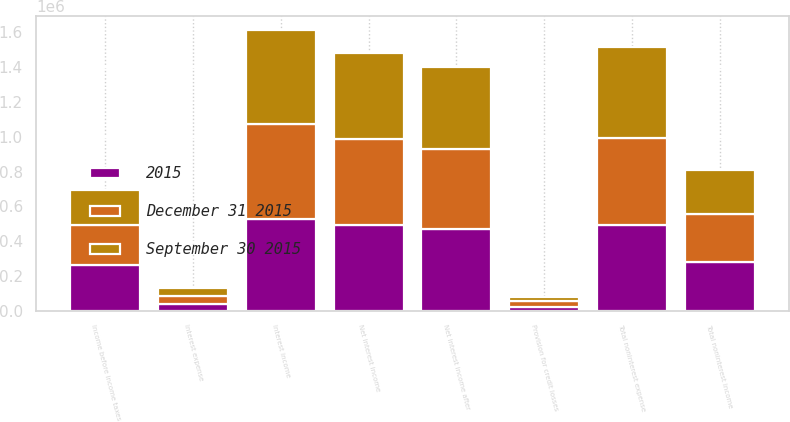Convert chart to OTSL. <chart><loc_0><loc_0><loc_500><loc_500><stacked_bar_chart><ecel><fcel>Interest income<fcel>Interest expense<fcel>Net interest income<fcel>Provision for credit losses<fcel>Net interest income after<fcel>Total noninterest income<fcel>Total noninterest expense<fcel>Income before income taxes<nl><fcel>December 31 2015<fcel>544153<fcel>47242<fcel>496911<fcel>36468<fcel>460443<fcel>272215<fcel>498766<fcel>233892<nl><fcel>September 30 2015<fcel>538477<fcel>43022<fcel>495455<fcel>22476<fcel>472979<fcel>253119<fcel>526508<fcel>199590<nl><fcel>2015<fcel>529795<fcel>39109<fcel>490686<fcel>20419<fcel>470267<fcel>281773<fcel>491777<fcel>260263<nl></chart> 